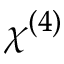Convert formula to latex. <formula><loc_0><loc_0><loc_500><loc_500>\chi ^ { ( 4 ) }</formula> 